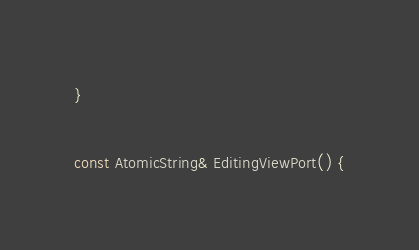<code> <loc_0><loc_0><loc_500><loc_500><_C++_>}

const AtomicString& EditingViewPort() {</code> 